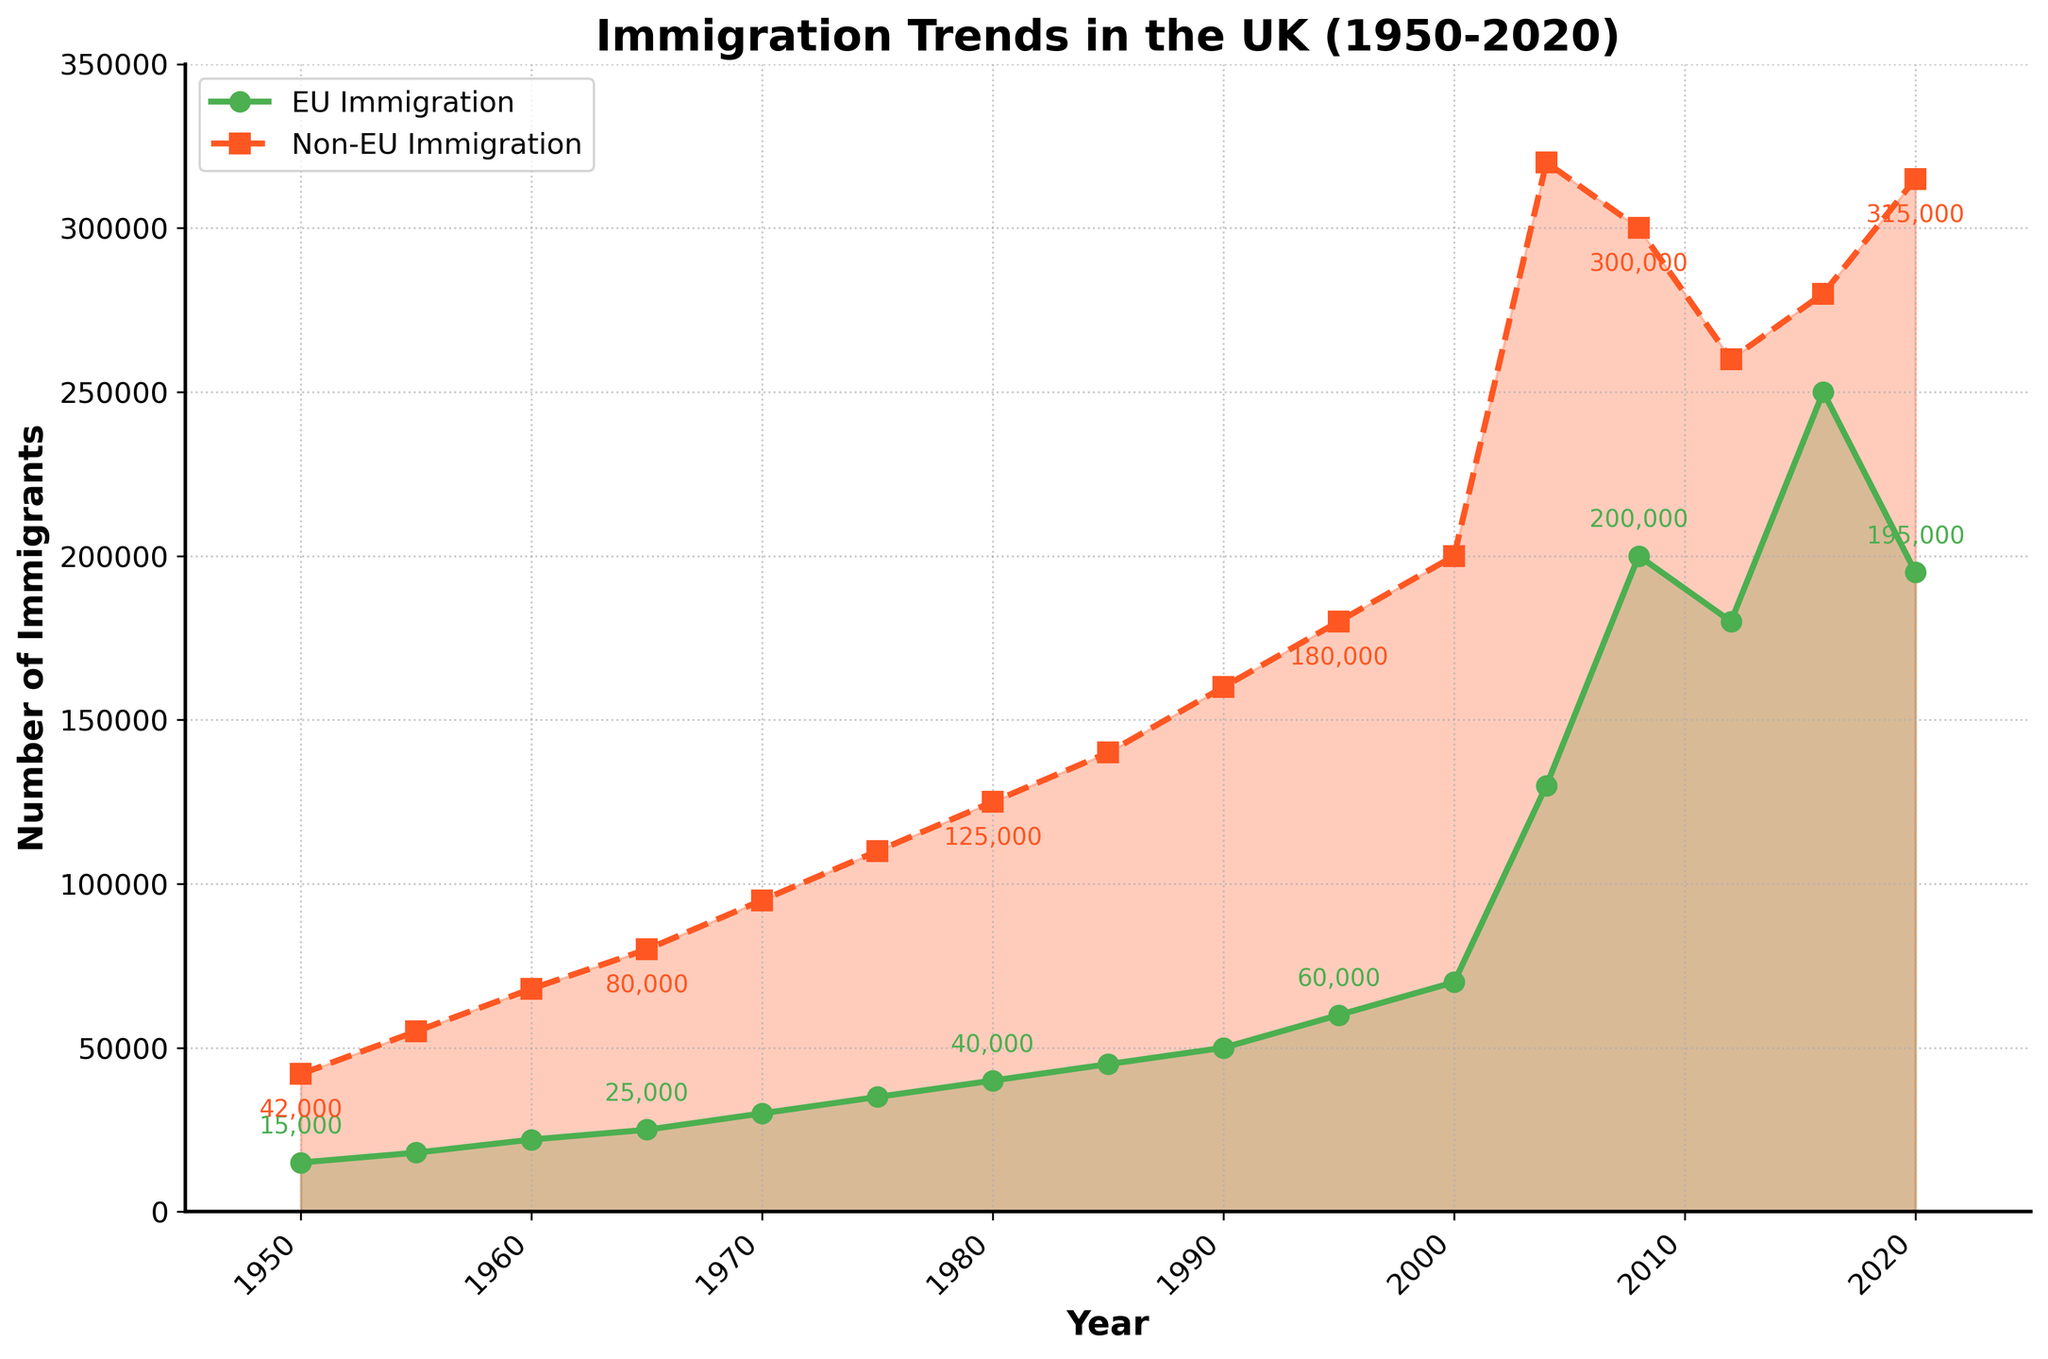What trend in EU and Non-EU immigration can be observed from the year 1950 to 2020? Both EU and Non-EU immigration show an increasing trend over the years. From 1950 to 2020, the number of immigrants from both regions continuously increased, although with some fluctuations, particularly for EU immigration.
Answer: Increasing trend for both Between 1950 and 2020, in which year did EU immigration first surpass 100,000? By examining the plotted points, EU immigration first surpasses 100,000 in the year 2004.
Answer: 2004 Which recorded year shows the highest number of Non-EU immigrants, and what is that number? By looking at the peak of the Non-EU immigration line (represented with squares and dashed lines), the year 2000 shows the highest number of Non-EU immigrants at 320,000.
Answer: 2000, 320,000 Was there any year when EU immigration decreased while Non-EU immigration increased? Observing the trends shows that this occurs during the period from 2008 to 2012 where EU immigration decreases (from 200,000 to 180,000) while Non-EU immigration decreases (from 300,000 to 260,000).
Answer: 2008 to 2012 Comparing the general trend, did EU immigration ever exceed Non-EU immigration? Even though EU immigration increases significantly over time, it never exceeds Non-EU immigration in the displayed years.
Answer: No How did the number of Non-EU immigrants change between 1990 and 2004? The number of Non-EU immigrants increased from 160,000 in 1990 to 320,000 in 2004.
Answer: Doubled Which immigration type experienced the most significant increase between 2000 and 2004? From visual observation, EU immigration increased from 70,000 in 2000 to 130,000 in 2004, a rise of 60,000. Non-EU immigration didn’t increase as much in the same period.
Answer: EU immigration What specific visual feature helps distinguish between EU and Non-EU immigration trends in the line chart? EU immigration is represented using green lines with circular markers and solid lines, while Non-EU immigration is represented using red lines with square markers and dashed lines. Additionally, EU immigration is filled with a light green area, and Non-EU immigration with light red.
Answer: Different markers and line styles Between what years did both immigration types see a decrease in numbers? Both EU and Non-EU immigration saw a simultaneous decrease between the years 2008 to 2012.
Answer: 2008 to 2012 